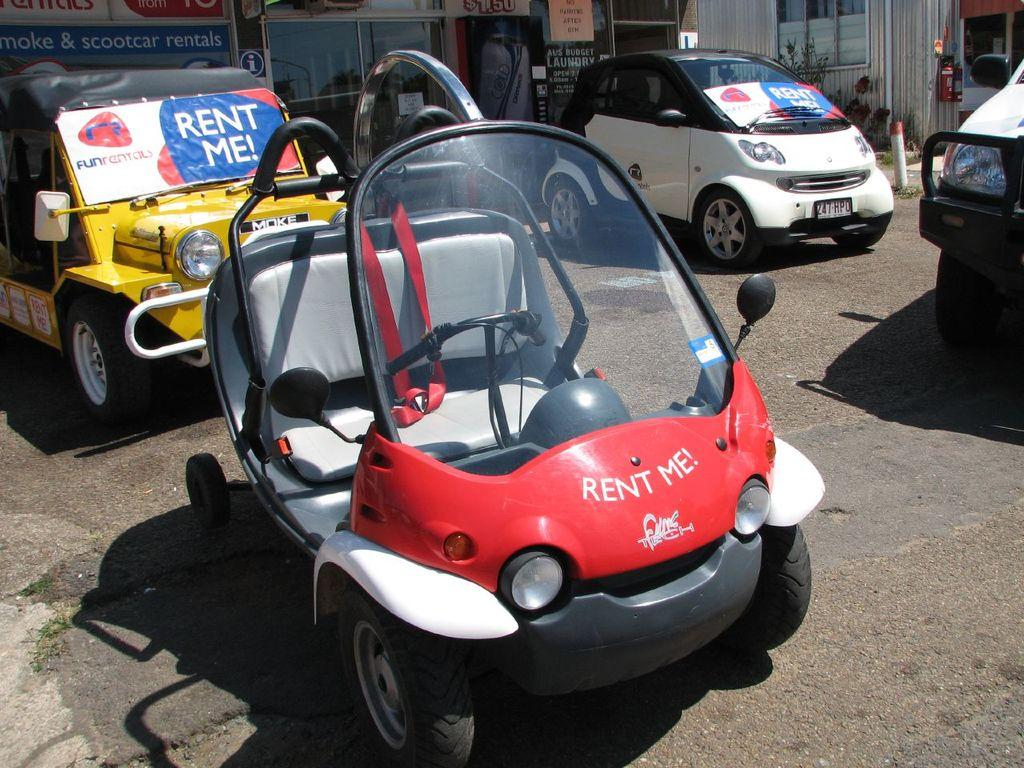What can be seen in the foreground of the image? In the foreground, there are vehicles on the road, grass, and poles. What is visible in the background of the image? In the background, there are buildings, windows, boards, and houseplants. Can you describe the time of day when the image was taken? The image was likely taken during the day, as there is sufficient light to see the details clearly. How many masses can be seen in the image? There is no mass present in the image. Is there a wire connecting the vehicles in the foreground? There is no wire connecting the vehicles in the image. Can you spot any deer in the background? There are no deer present in the image. 